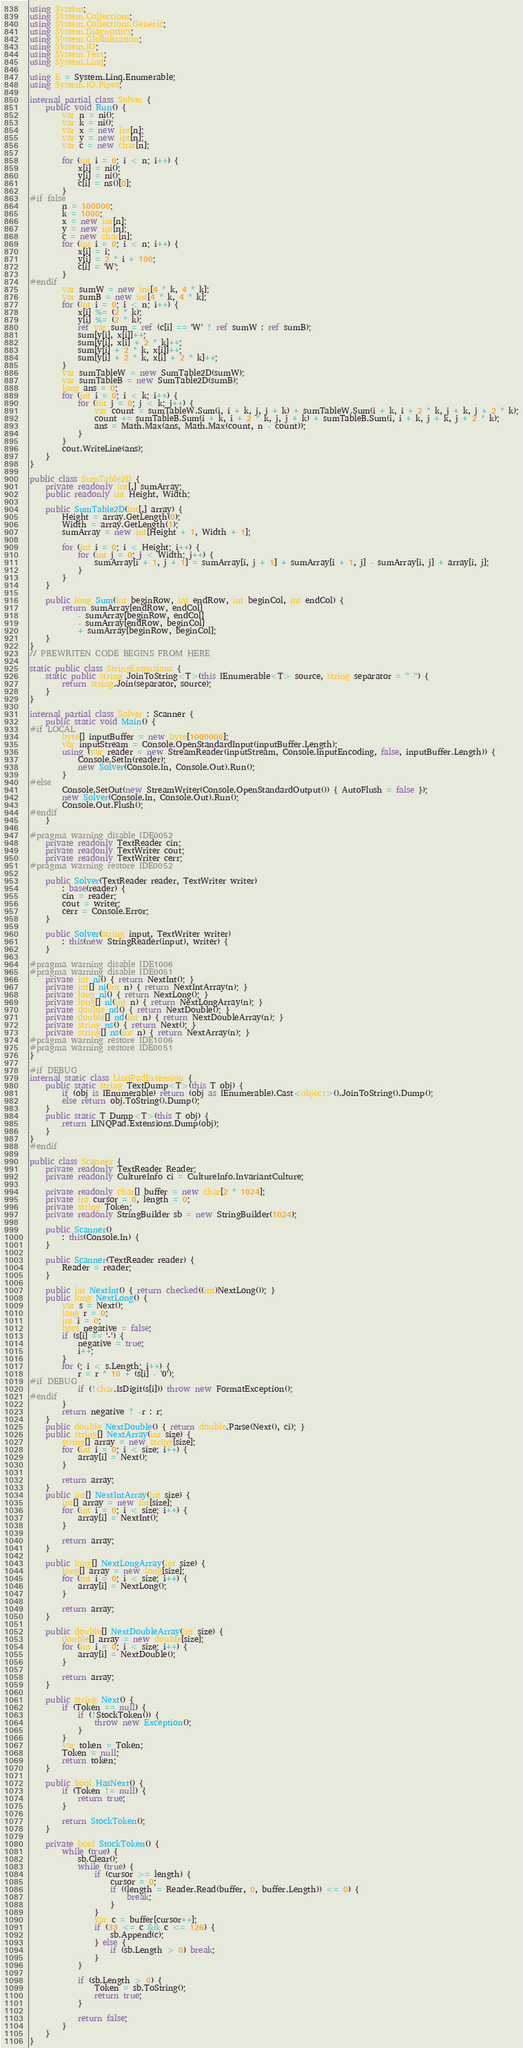Convert code to text. <code><loc_0><loc_0><loc_500><loc_500><_C#_>using System;
using System.Collections;
using System.Collections.Generic;
using System.Diagnostics;
using System.Globalization;
using System.IO;
using System.Text;
using System.Linq;

using E = System.Linq.Enumerable;
using System.IO.Pipes;

internal partial class Solver {
    public void Run() {
        var n = ni();
        var k = ni();
        var x = new int[n];
        var y = new int[n];
        var c = new char[n];

        for (int i = 0; i < n; i++) {
            x[i] = ni();
            y[i] = ni();
            c[i] = ns()[0];
        }
#if false
        n = 100000;
        k = 1000;
        x = new int[n];
        y = new int[n];
        c = new char[n];
        for (int i = 0; i < n; i++) {
            x[i] = i;
            y[i] = 2 * i + 100;
            c[i] = 'W';
        }
#endif
        var sumW = new int[4 * k, 4 * k];
        var sumB = new int[4 * k, 4 * k];
        for (int i = 0; i < n; i++) {
            x[i] %= (2 * k);
            y[i] %= (2 * k);
            ref var sum = ref (c[i] == 'W' ? ref sumW : ref sumB);
            sum[y[i], x[i]]++;
            sum[y[i], x[i] + 2 * k]++;
            sum[y[i] + 2 * k, x[i]]++;
            sum[y[i] + 2 * k, x[i] + 2 * k]++;
        }
        var sumTableW = new SumTable2D(sumW);
        var sumTableB = new SumTable2D(sumB);
        long ans = 0;
        for (int i = 0; i < k; i++) {
            for (int j = 0; j < k; j++) {
                var count = sumTableW.Sum(i, i + k, j, j + k) + sumTableW.Sum(i + k, i + 2 * k, j + k, j + 2 * k);
                count += sumTableB.Sum(i + k, i + 2 * k, j, j + k) + sumTableB.Sum(i, i + k, j + k, j + 2 * k);
                ans = Math.Max(ans, Math.Max(count, n - count));
            }
        }
        cout.WriteLine(ans);
    }
}

public class SumTable2D {
    private readonly int[,] sumArray;
    public readonly int Height, Width;

    public SumTable2D(int[,] array) {
        Height = array.GetLength(0);
        Width = array.GetLength(1);
        sumArray = new int[Height + 1, Width + 1];

        for (int i = 0; i < Height; i++) {
            for (int j = 0; j < Width; j++) {
                sumArray[i + 1, j + 1] = sumArray[i, j + 1] + sumArray[i + 1, j] - sumArray[i, j] + array[i, j];
            }
        }
    }

    public long Sum(int beginRow, int endRow, int beginCol, int endCol) {
        return sumArray[endRow, endCol]
            - sumArray[beginRow, endCol]
            - sumArray[endRow, beginCol]
            + sumArray[beginRow, beginCol];
    }
}
// PREWRITEN CODE BEGINS FROM HERE

static public class StringExtensions {
    static public string JoinToString<T>(this IEnumerable<T> source, string separator = " ") {
        return string.Join(separator, source);
    }
}

internal partial class Solver : Scanner {
    public static void Main() {
#if LOCAL
        byte[] inputBuffer = new byte[1000000];
        var inputStream = Console.OpenStandardInput(inputBuffer.Length);
        using (var reader = new StreamReader(inputStream, Console.InputEncoding, false, inputBuffer.Length)) {
            Console.SetIn(reader);
            new Solver(Console.In, Console.Out).Run();
        }
#else
        Console.SetOut(new StreamWriter(Console.OpenStandardOutput()) { AutoFlush = false });
        new Solver(Console.In, Console.Out).Run();
        Console.Out.Flush();
#endif
    }

#pragma warning disable IDE0052
    private readonly TextReader cin;
    private readonly TextWriter cout;
    private readonly TextWriter cerr;
#pragma warning restore IDE0052

    public Solver(TextReader reader, TextWriter writer)
        : base(reader) {
        cin = reader;
        cout = writer;
        cerr = Console.Error;
    }

    public Solver(string input, TextWriter writer)
        : this(new StringReader(input), writer) {
    }

#pragma warning disable IDE1006
#pragma warning disable IDE0051
    private int ni() { return NextInt(); }
    private int[] ni(int n) { return NextIntArray(n); }
    private long nl() { return NextLong(); }
    private long[] nl(int n) { return NextLongArray(n); }
    private double nd() { return NextDouble(); }
    private double[] nd(int n) { return NextDoubleArray(n); }
    private string ns() { return Next(); }
    private string[] ns(int n) { return NextArray(n); }
#pragma warning restore IDE1006
#pragma warning restore IDE0051
}

#if DEBUG
internal static class LinqPadExtension {
    public static string TextDump<T>(this T obj) {
        if (obj is IEnumerable) return (obj as IEnumerable).Cast<object>().JoinToString().Dump();
        else return obj.ToString().Dump();
    }
    public static T Dump<T>(this T obj) {
        return LINQPad.Extensions.Dump(obj);
    }
}
#endif

public class Scanner {
    private readonly TextReader Reader;
    private readonly CultureInfo ci = CultureInfo.InvariantCulture;

    private readonly char[] buffer = new char[2 * 1024];
    private int cursor = 0, length = 0;
    private string Token;
    private readonly StringBuilder sb = new StringBuilder(1024);

    public Scanner()
        : this(Console.In) {
    }

    public Scanner(TextReader reader) {
        Reader = reader;
    }

    public int NextInt() { return checked((int)NextLong()); }
    public long NextLong() {
        var s = Next();
        long r = 0;
        int i = 0;
        bool negative = false;
        if (s[i] == '-') {
            negative = true;
            i++;
        }
        for (; i < s.Length; i++) {
            r = r * 10 + (s[i] - '0');
#if DEBUG
            if (!char.IsDigit(s[i])) throw new FormatException();
#endif
        }
        return negative ? -r : r;
    }
    public double NextDouble() { return double.Parse(Next(), ci); }
    public string[] NextArray(int size) {
        string[] array = new string[size];
        for (int i = 0; i < size; i++) {
            array[i] = Next();
        }

        return array;
    }
    public int[] NextIntArray(int size) {
        int[] array = new int[size];
        for (int i = 0; i < size; i++) {
            array[i] = NextInt();
        }

        return array;
    }

    public long[] NextLongArray(int size) {
        long[] array = new long[size];
        for (int i = 0; i < size; i++) {
            array[i] = NextLong();
        }

        return array;
    }

    public double[] NextDoubleArray(int size) {
        double[] array = new double[size];
        for (int i = 0; i < size; i++) {
            array[i] = NextDouble();
        }

        return array;
    }

    public string Next() {
        if (Token == null) {
            if (!StockToken()) {
                throw new Exception();
            }
        }
        var token = Token;
        Token = null;
        return token;
    }

    public bool HasNext() {
        if (Token != null) {
            return true;
        }

        return StockToken();
    }

    private bool StockToken() {
        while (true) {
            sb.Clear();
            while (true) {
                if (cursor >= length) {
                    cursor = 0;
                    if ((length = Reader.Read(buffer, 0, buffer.Length)) <= 0) {
                        break;
                    }
                }
                var c = buffer[cursor++];
                if (33 <= c && c <= 126) {
                    sb.Append(c);
                } else {
                    if (sb.Length > 0) break;
                }
            }

            if (sb.Length > 0) {
                Token = sb.ToString();
                return true;
            }

            return false;
        }
    }
}</code> 